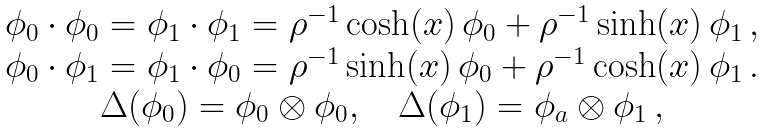Convert formula to latex. <formula><loc_0><loc_0><loc_500><loc_500>\begin{array} { c c c } \phi _ { 0 } \cdot \phi _ { 0 } = \phi _ { 1 } \cdot \phi _ { 1 } = \rho ^ { - 1 } \cosh ( x ) \, \phi _ { 0 } + \rho ^ { - 1 } \sinh ( x ) \, \phi _ { 1 } \, , \\ \phi _ { 0 } \cdot \phi _ { 1 } = \phi _ { 1 } \cdot \phi _ { 0 } = \rho ^ { - 1 } \sinh ( x ) \, \phi _ { 0 } + \rho ^ { - 1 } \cosh ( x ) \, \phi _ { 1 } \, . \\ \Delta ( \phi _ { 0 } ) = \phi _ { 0 } \otimes \phi _ { 0 } , \quad \Delta ( \phi _ { 1 } ) = \phi _ { a } \otimes \phi _ { 1 } \, , \end{array}</formula> 